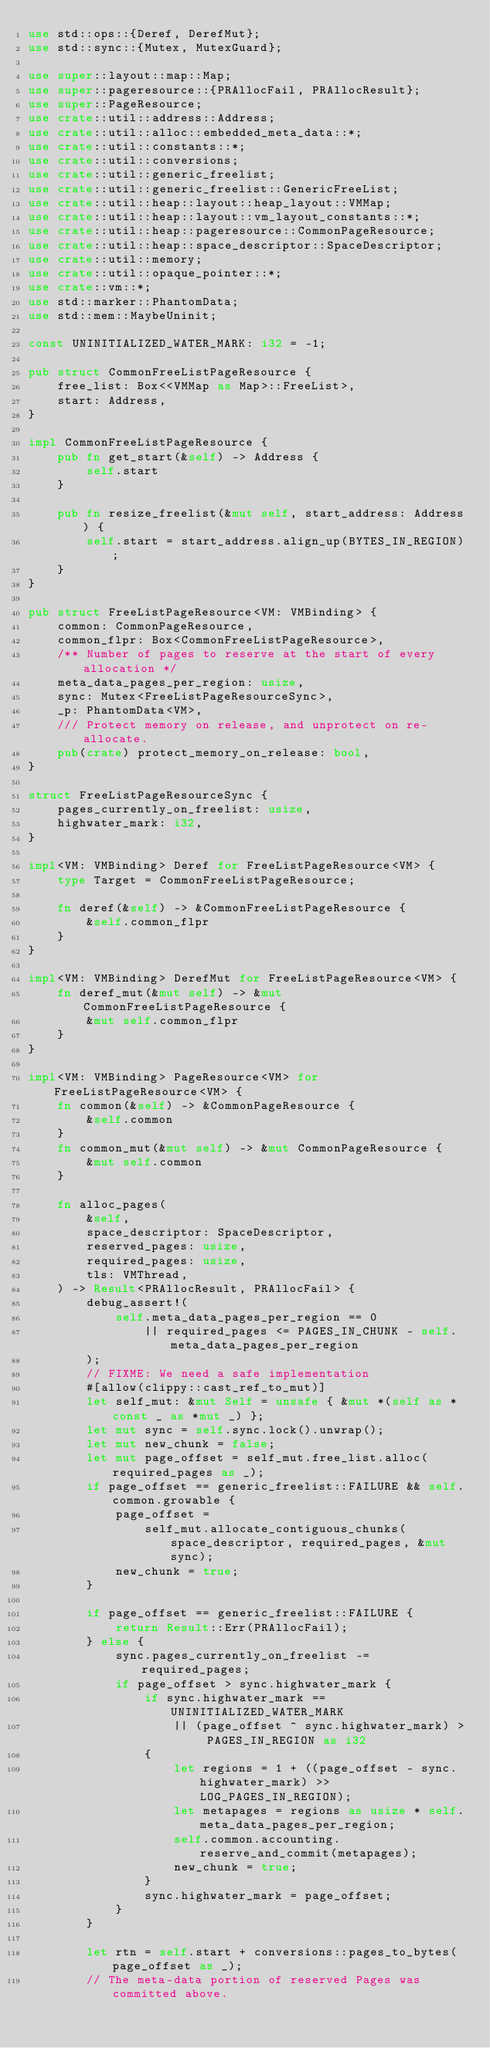<code> <loc_0><loc_0><loc_500><loc_500><_Rust_>use std::ops::{Deref, DerefMut};
use std::sync::{Mutex, MutexGuard};

use super::layout::map::Map;
use super::pageresource::{PRAllocFail, PRAllocResult};
use super::PageResource;
use crate::util::address::Address;
use crate::util::alloc::embedded_meta_data::*;
use crate::util::constants::*;
use crate::util::conversions;
use crate::util::generic_freelist;
use crate::util::generic_freelist::GenericFreeList;
use crate::util::heap::layout::heap_layout::VMMap;
use crate::util::heap::layout::vm_layout_constants::*;
use crate::util::heap::pageresource::CommonPageResource;
use crate::util::heap::space_descriptor::SpaceDescriptor;
use crate::util::memory;
use crate::util::opaque_pointer::*;
use crate::vm::*;
use std::marker::PhantomData;
use std::mem::MaybeUninit;

const UNINITIALIZED_WATER_MARK: i32 = -1;

pub struct CommonFreeListPageResource {
    free_list: Box<<VMMap as Map>::FreeList>,
    start: Address,
}

impl CommonFreeListPageResource {
    pub fn get_start(&self) -> Address {
        self.start
    }

    pub fn resize_freelist(&mut self, start_address: Address) {
        self.start = start_address.align_up(BYTES_IN_REGION);
    }
}

pub struct FreeListPageResource<VM: VMBinding> {
    common: CommonPageResource,
    common_flpr: Box<CommonFreeListPageResource>,
    /** Number of pages to reserve at the start of every allocation */
    meta_data_pages_per_region: usize,
    sync: Mutex<FreeListPageResourceSync>,
    _p: PhantomData<VM>,
    /// Protect memory on release, and unprotect on re-allocate.
    pub(crate) protect_memory_on_release: bool,
}

struct FreeListPageResourceSync {
    pages_currently_on_freelist: usize,
    highwater_mark: i32,
}

impl<VM: VMBinding> Deref for FreeListPageResource<VM> {
    type Target = CommonFreeListPageResource;

    fn deref(&self) -> &CommonFreeListPageResource {
        &self.common_flpr
    }
}

impl<VM: VMBinding> DerefMut for FreeListPageResource<VM> {
    fn deref_mut(&mut self) -> &mut CommonFreeListPageResource {
        &mut self.common_flpr
    }
}

impl<VM: VMBinding> PageResource<VM> for FreeListPageResource<VM> {
    fn common(&self) -> &CommonPageResource {
        &self.common
    }
    fn common_mut(&mut self) -> &mut CommonPageResource {
        &mut self.common
    }

    fn alloc_pages(
        &self,
        space_descriptor: SpaceDescriptor,
        reserved_pages: usize,
        required_pages: usize,
        tls: VMThread,
    ) -> Result<PRAllocResult, PRAllocFail> {
        debug_assert!(
            self.meta_data_pages_per_region == 0
                || required_pages <= PAGES_IN_CHUNK - self.meta_data_pages_per_region
        );
        // FIXME: We need a safe implementation
        #[allow(clippy::cast_ref_to_mut)]
        let self_mut: &mut Self = unsafe { &mut *(self as *const _ as *mut _) };
        let mut sync = self.sync.lock().unwrap();
        let mut new_chunk = false;
        let mut page_offset = self_mut.free_list.alloc(required_pages as _);
        if page_offset == generic_freelist::FAILURE && self.common.growable {
            page_offset =
                self_mut.allocate_contiguous_chunks(space_descriptor, required_pages, &mut sync);
            new_chunk = true;
        }

        if page_offset == generic_freelist::FAILURE {
            return Result::Err(PRAllocFail);
        } else {
            sync.pages_currently_on_freelist -= required_pages;
            if page_offset > sync.highwater_mark {
                if sync.highwater_mark == UNINITIALIZED_WATER_MARK
                    || (page_offset ^ sync.highwater_mark) > PAGES_IN_REGION as i32
                {
                    let regions = 1 + ((page_offset - sync.highwater_mark) >> LOG_PAGES_IN_REGION);
                    let metapages = regions as usize * self.meta_data_pages_per_region;
                    self.common.accounting.reserve_and_commit(metapages);
                    new_chunk = true;
                }
                sync.highwater_mark = page_offset;
            }
        }

        let rtn = self.start + conversions::pages_to_bytes(page_offset as _);
        // The meta-data portion of reserved Pages was committed above.</code> 